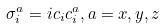<formula> <loc_0><loc_0><loc_500><loc_500>\sigma ^ { a } _ { i } = i c _ { i } c _ { i } ^ { a } , a = x , y , z</formula> 